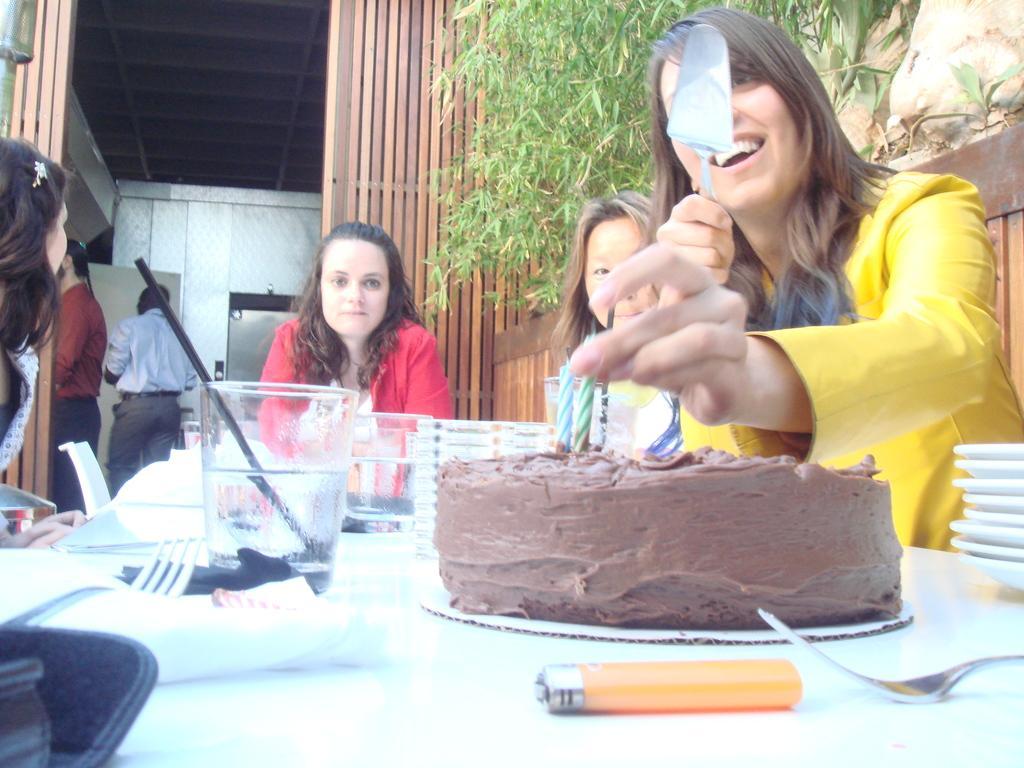How would you summarize this image in a sentence or two? This picture shows few people seated on the chair and a woman holding a serving spoon and we see a cake and a lighter and we see glasses and a fork and few plates on the table and we see a man holding a candle and we see plants and couple of men standing on the side. 